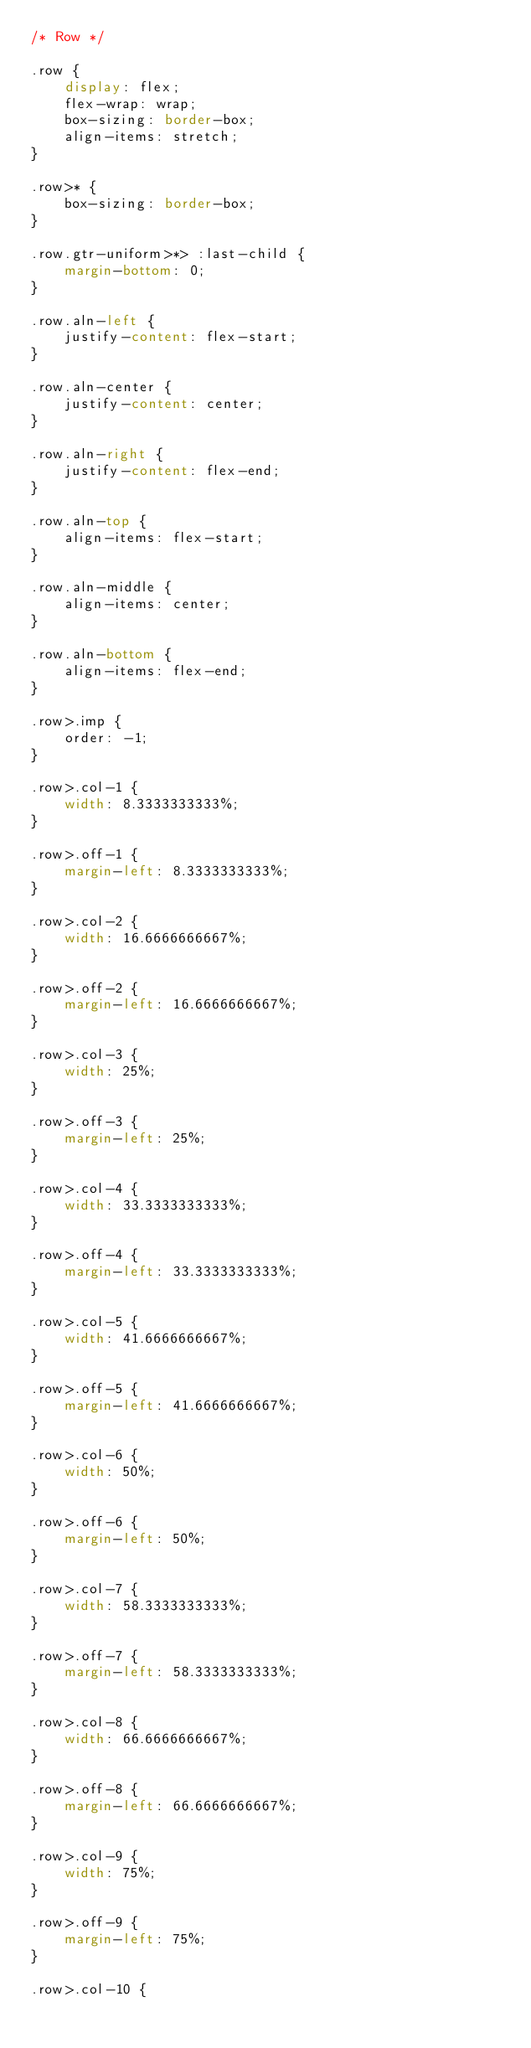Convert code to text. <code><loc_0><loc_0><loc_500><loc_500><_CSS_>/* Row */

.row {
    display: flex;
    flex-wrap: wrap;
    box-sizing: border-box;
    align-items: stretch;
}

.row>* {
    box-sizing: border-box;
}

.row.gtr-uniform>*> :last-child {
    margin-bottom: 0;
}

.row.aln-left {
    justify-content: flex-start;
}

.row.aln-center {
    justify-content: center;
}

.row.aln-right {
    justify-content: flex-end;
}

.row.aln-top {
    align-items: flex-start;
}

.row.aln-middle {
    align-items: center;
}

.row.aln-bottom {
    align-items: flex-end;
}

.row>.imp {
    order: -1;
}

.row>.col-1 {
    width: 8.3333333333%;
}

.row>.off-1 {
    margin-left: 8.3333333333%;
}

.row>.col-2 {
    width: 16.6666666667%;
}

.row>.off-2 {
    margin-left: 16.6666666667%;
}

.row>.col-3 {
    width: 25%;
}

.row>.off-3 {
    margin-left: 25%;
}

.row>.col-4 {
    width: 33.3333333333%;
}

.row>.off-4 {
    margin-left: 33.3333333333%;
}

.row>.col-5 {
    width: 41.6666666667%;
}

.row>.off-5 {
    margin-left: 41.6666666667%;
}

.row>.col-6 {
    width: 50%;
}

.row>.off-6 {
    margin-left: 50%;
}

.row>.col-7 {
    width: 58.3333333333%;
}

.row>.off-7 {
    margin-left: 58.3333333333%;
}

.row>.col-8 {
    width: 66.6666666667%;
}

.row>.off-8 {
    margin-left: 66.6666666667%;
}

.row>.col-9 {
    width: 75%;
}

.row>.off-9 {
    margin-left: 75%;
}

.row>.col-10 {</code> 